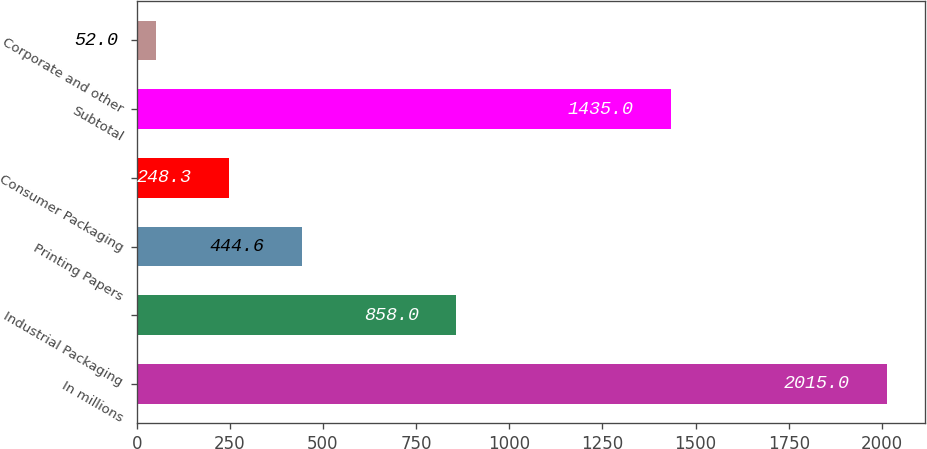<chart> <loc_0><loc_0><loc_500><loc_500><bar_chart><fcel>In millions<fcel>Industrial Packaging<fcel>Printing Papers<fcel>Consumer Packaging<fcel>Subtotal<fcel>Corporate and other<nl><fcel>2015<fcel>858<fcel>444.6<fcel>248.3<fcel>1435<fcel>52<nl></chart> 